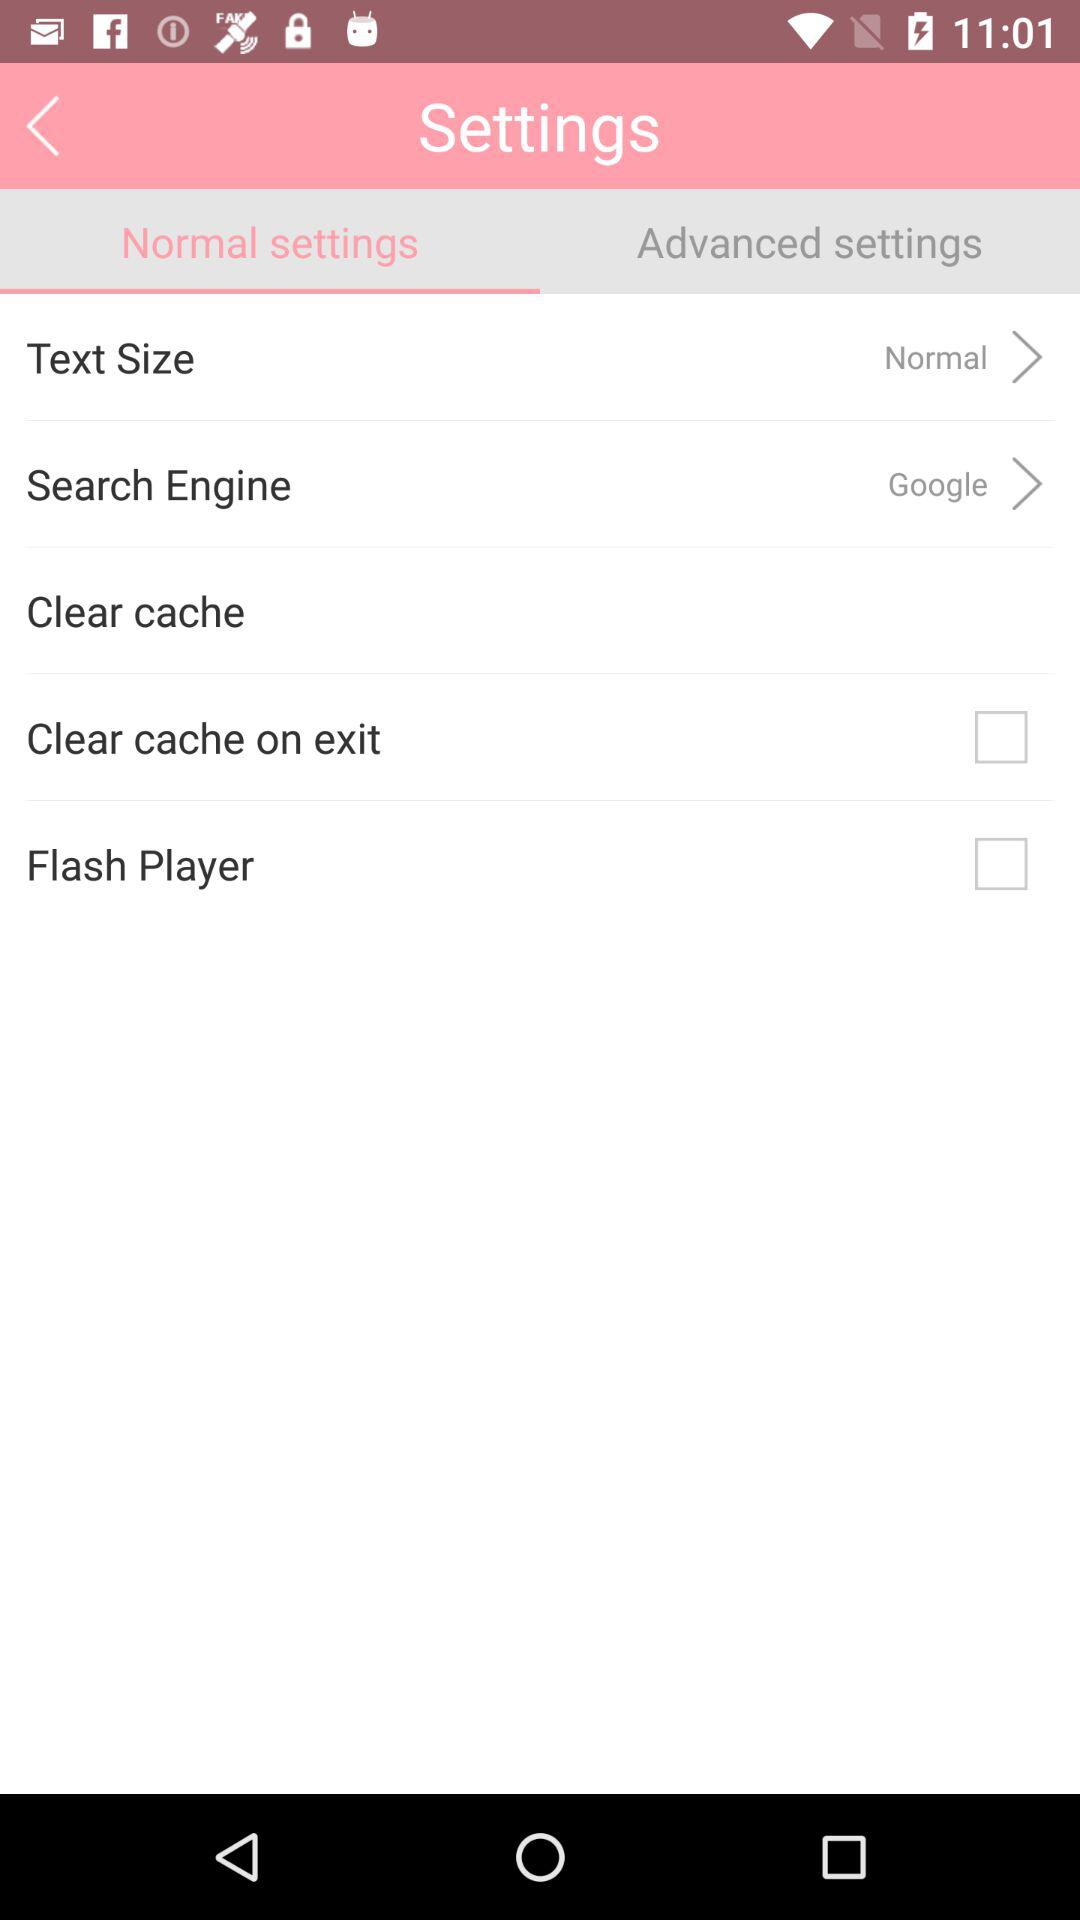What is the text size? The text size is "Normal". 